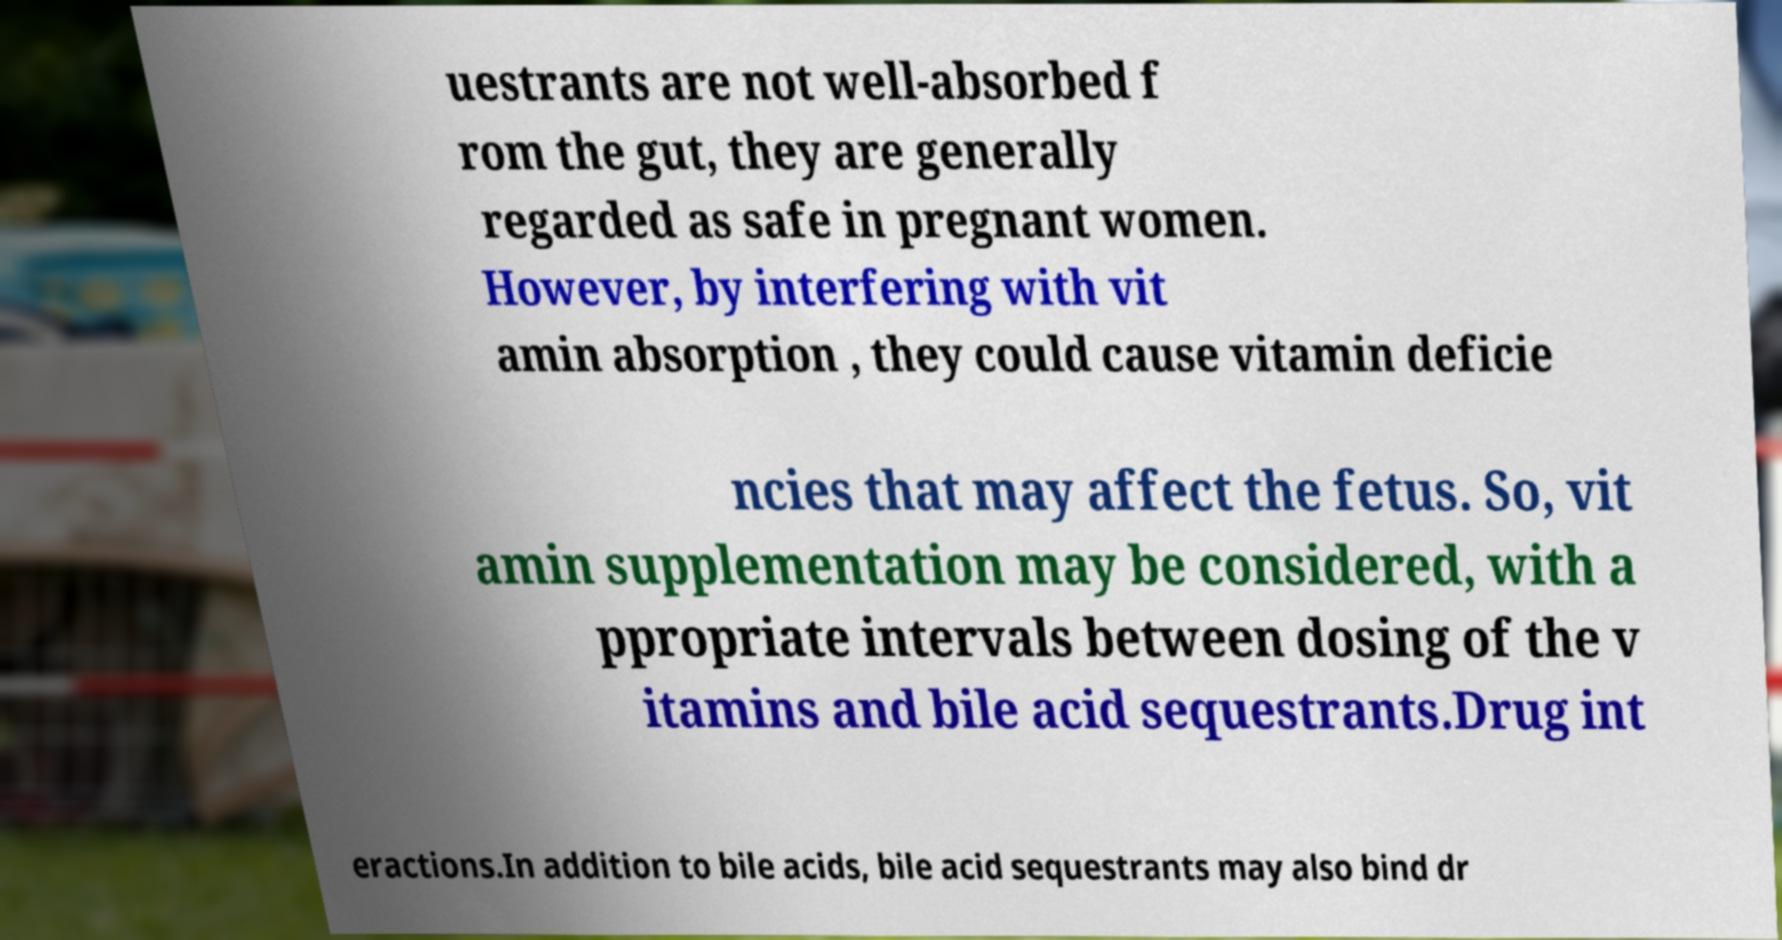What messages or text are displayed in this image? I need them in a readable, typed format. uestrants are not well-absorbed f rom the gut, they are generally regarded as safe in pregnant women. However, by interfering with vit amin absorption , they could cause vitamin deficie ncies that may affect the fetus. So, vit amin supplementation may be considered, with a ppropriate intervals between dosing of the v itamins and bile acid sequestrants.Drug int eractions.In addition to bile acids, bile acid sequestrants may also bind dr 